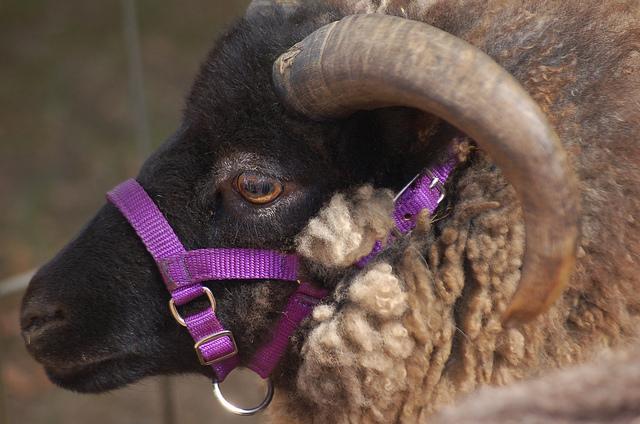Is this animal a pet?
Write a very short answer. Yes. What is the purple object on the ram's face?
Short answer required. Harness. Does this animal have a tail?
Quick response, please. Yes. 